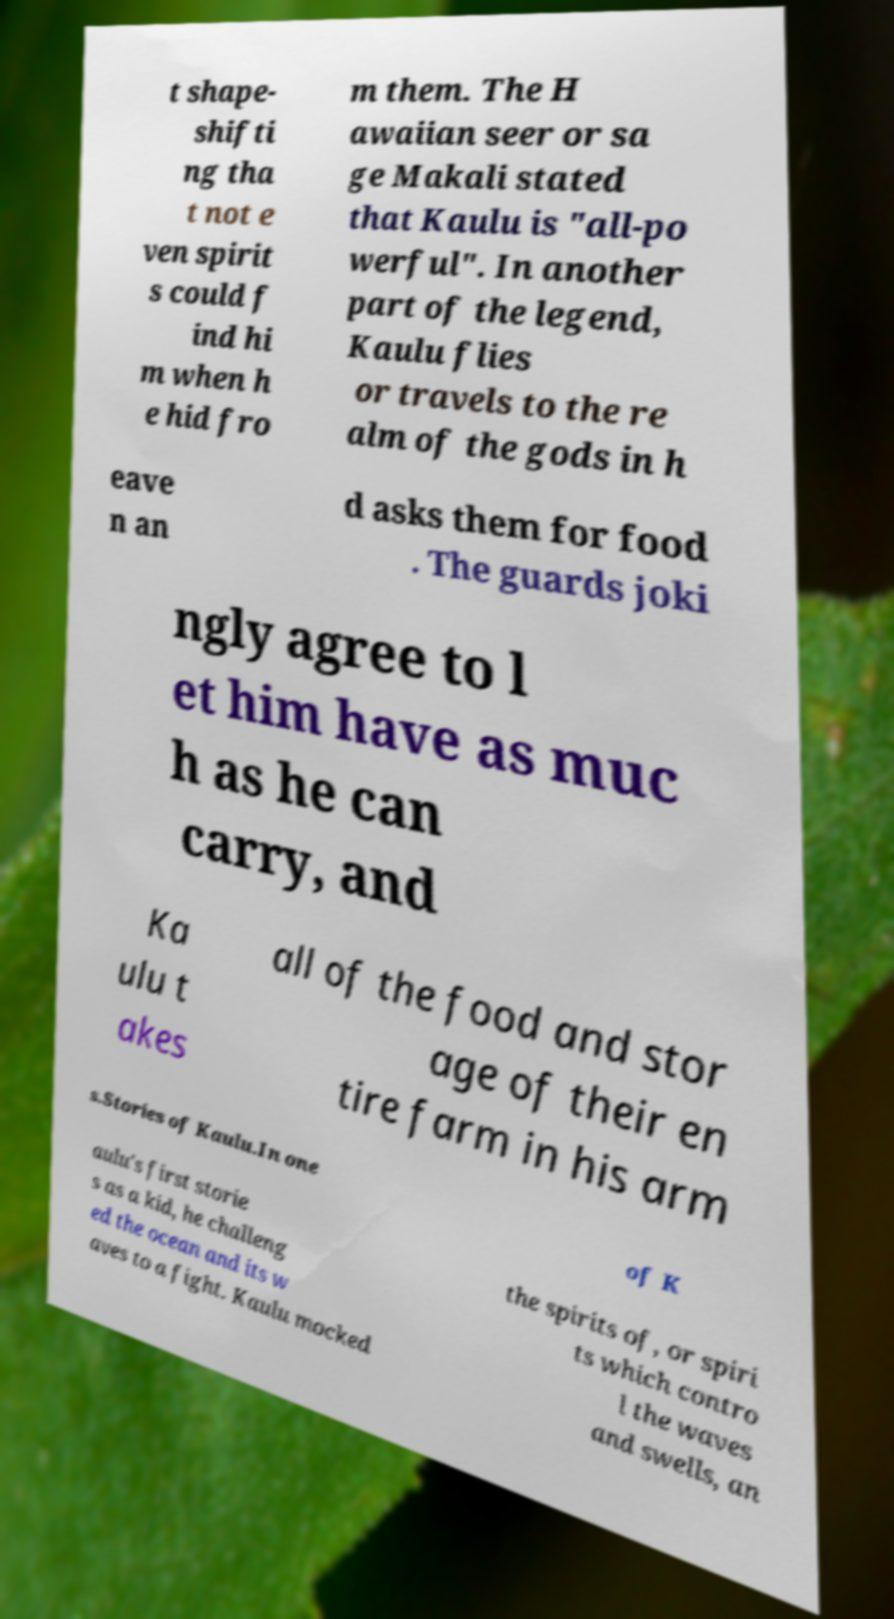Can you read and provide the text displayed in the image?This photo seems to have some interesting text. Can you extract and type it out for me? t shape- shifti ng tha t not e ven spirit s could f ind hi m when h e hid fro m them. The H awaiian seer or sa ge Makali stated that Kaulu is "all-po werful". In another part of the legend, Kaulu flies or travels to the re alm of the gods in h eave n an d asks them for food . The guards joki ngly agree to l et him have as muc h as he can carry, and Ka ulu t akes all of the food and stor age of their en tire farm in his arm s.Stories of Kaulu.In one of K aulu's first storie s as a kid, he challeng ed the ocean and its w aves to a fight. Kaulu mocked the spirits of, or spiri ts which contro l the waves and swells, an 